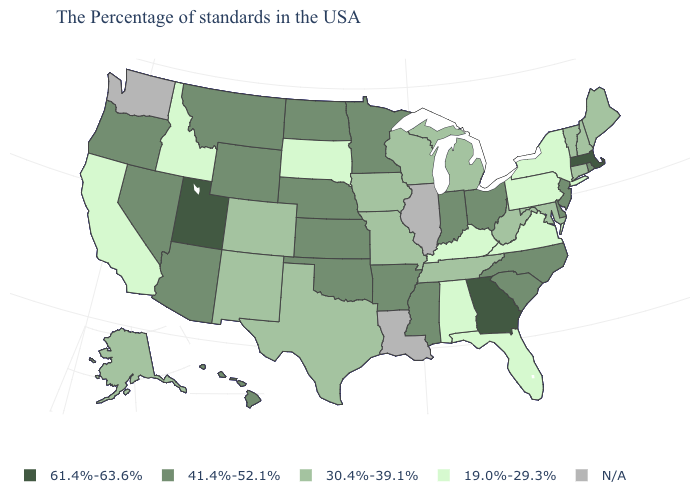Among the states that border New Jersey , which have the lowest value?
Give a very brief answer. New York, Pennsylvania. What is the lowest value in the USA?
Quick response, please. 19.0%-29.3%. Name the states that have a value in the range N/A?
Be succinct. Illinois, Louisiana, Washington. How many symbols are there in the legend?
Write a very short answer. 5. Name the states that have a value in the range 19.0%-29.3%?
Keep it brief. New York, Pennsylvania, Virginia, Florida, Kentucky, Alabama, South Dakota, Idaho, California. Among the states that border Connecticut , which have the lowest value?
Give a very brief answer. New York. Name the states that have a value in the range 41.4%-52.1%?
Give a very brief answer. Rhode Island, New Jersey, Delaware, North Carolina, South Carolina, Ohio, Indiana, Mississippi, Arkansas, Minnesota, Kansas, Nebraska, Oklahoma, North Dakota, Wyoming, Montana, Arizona, Nevada, Oregon, Hawaii. What is the lowest value in the USA?
Be succinct. 19.0%-29.3%. Name the states that have a value in the range 41.4%-52.1%?
Give a very brief answer. Rhode Island, New Jersey, Delaware, North Carolina, South Carolina, Ohio, Indiana, Mississippi, Arkansas, Minnesota, Kansas, Nebraska, Oklahoma, North Dakota, Wyoming, Montana, Arizona, Nevada, Oregon, Hawaii. Name the states that have a value in the range 61.4%-63.6%?
Quick response, please. Massachusetts, Georgia, Utah. Name the states that have a value in the range N/A?
Short answer required. Illinois, Louisiana, Washington. Which states have the lowest value in the South?
Keep it brief. Virginia, Florida, Kentucky, Alabama. Name the states that have a value in the range 30.4%-39.1%?
Answer briefly. Maine, New Hampshire, Vermont, Connecticut, Maryland, West Virginia, Michigan, Tennessee, Wisconsin, Missouri, Iowa, Texas, Colorado, New Mexico, Alaska. What is the highest value in the USA?
Concise answer only. 61.4%-63.6%. 